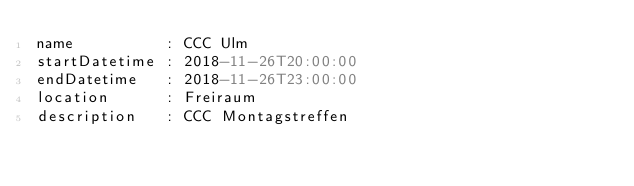Convert code to text. <code><loc_0><loc_0><loc_500><loc_500><_YAML_>name          : CCC Ulm
startDatetime : 2018-11-26T20:00:00
endDatetime   : 2018-11-26T23:00:00
location      : Freiraum
description   : CCC Montagstreffen
</code> 